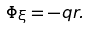<formula> <loc_0><loc_0><loc_500><loc_500>\Phi _ { \xi } = - q r .</formula> 